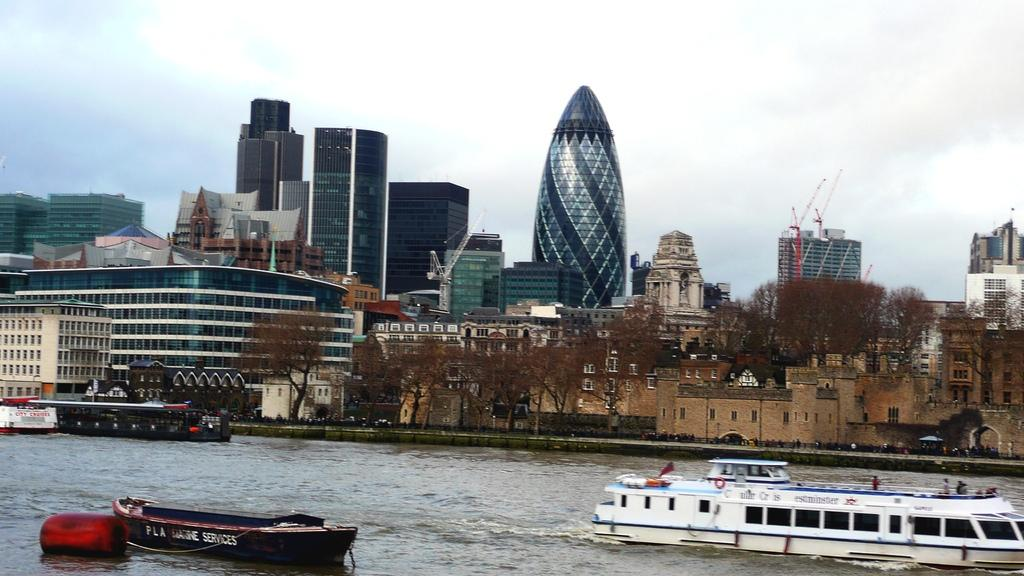What can be seen at the bottom of the image? There are boats in the water at the bottom of the image. What is located in the middle of the image? There are trees and buildings in the middle of the image. What is visible at the top of the image? The sky is visible at the top of the image. What type of juice is being served in the image? There is no juice present in the image. Can you hear a bell ringing in the image? There is no bell present in the image, so it is not possible to hear it ringing. 